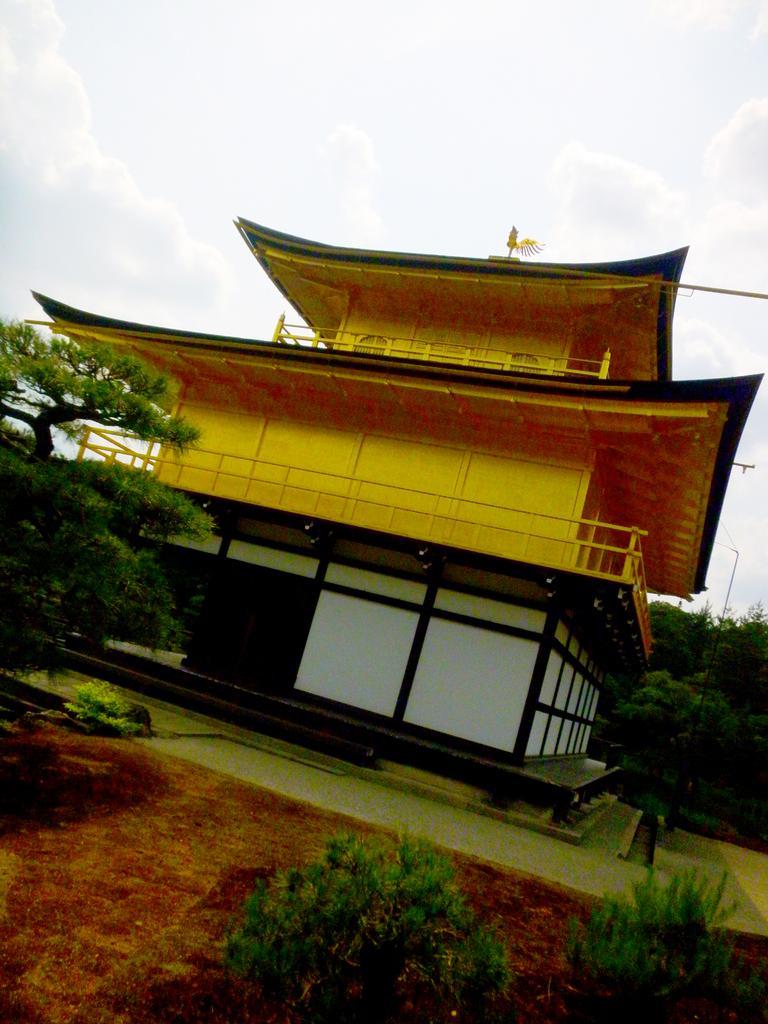Can you describe this image briefly? In this image, we can see some trees and plants. There is building in the middle of the image. There is a sky at the top of the image. 